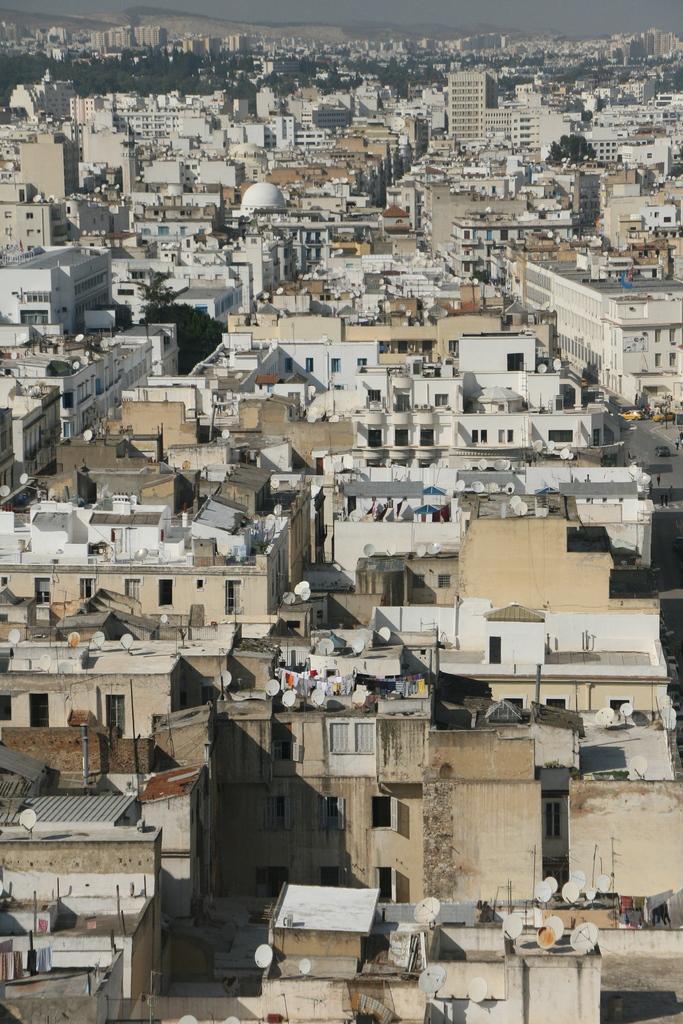Could you give a brief overview of what you see in this image? In this picture we can see lots of buildings and on the buildings there are antennas and behind the buildings there are trees. 